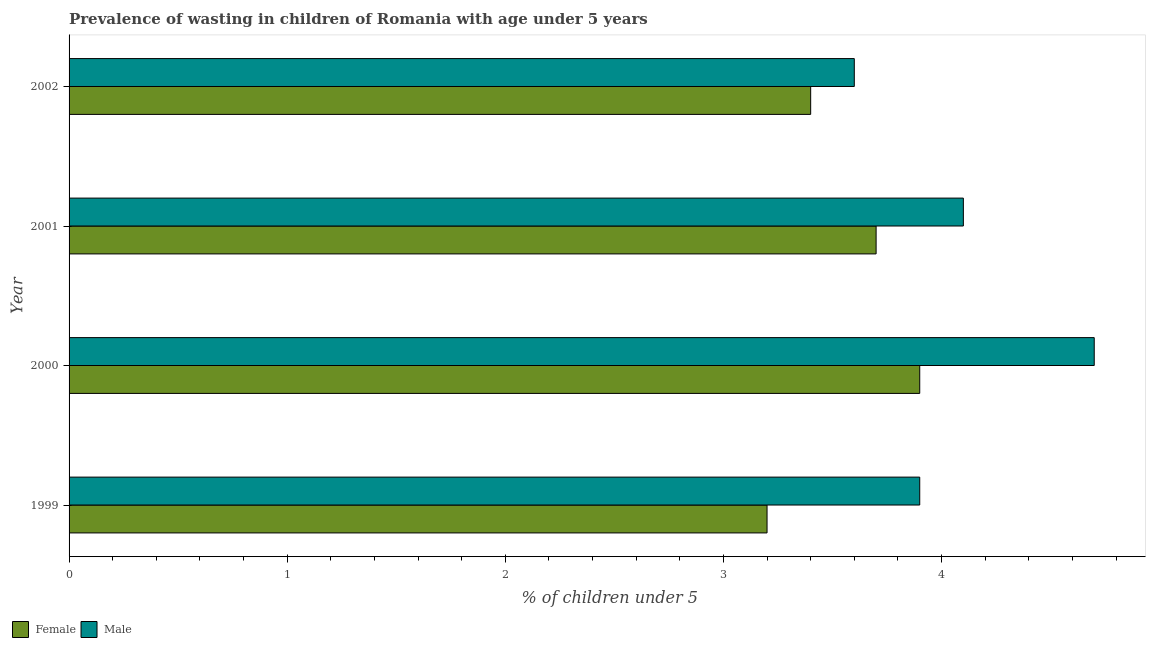How many groups of bars are there?
Your answer should be compact. 4. Are the number of bars per tick equal to the number of legend labels?
Give a very brief answer. Yes. How many bars are there on the 3rd tick from the top?
Your answer should be very brief. 2. How many bars are there on the 1st tick from the bottom?
Keep it short and to the point. 2. What is the label of the 4th group of bars from the top?
Provide a succinct answer. 1999. What is the percentage of undernourished female children in 1999?
Offer a very short reply. 3.2. Across all years, what is the maximum percentage of undernourished male children?
Your response must be concise. 4.7. Across all years, what is the minimum percentage of undernourished male children?
Ensure brevity in your answer.  3.6. What is the total percentage of undernourished male children in the graph?
Give a very brief answer. 16.3. What is the difference between the percentage of undernourished female children in 1999 and that in 2002?
Offer a terse response. -0.2. What is the average percentage of undernourished female children per year?
Ensure brevity in your answer.  3.55. In the year 2001, what is the difference between the percentage of undernourished male children and percentage of undernourished female children?
Offer a very short reply. 0.4. In how many years, is the percentage of undernourished male children greater than 1 %?
Provide a short and direct response. 4. What is the ratio of the percentage of undernourished female children in 1999 to that in 2001?
Ensure brevity in your answer.  0.86. Is the percentage of undernourished female children in 2001 less than that in 2002?
Provide a succinct answer. No. What is the difference between the highest and the second highest percentage of undernourished male children?
Your answer should be compact. 0.6. What is the difference between the highest and the lowest percentage of undernourished male children?
Provide a short and direct response. 1.1. In how many years, is the percentage of undernourished male children greater than the average percentage of undernourished male children taken over all years?
Make the answer very short. 2. Is the sum of the percentage of undernourished female children in 2000 and 2001 greater than the maximum percentage of undernourished male children across all years?
Make the answer very short. Yes. What does the 2nd bar from the top in 2000 represents?
Ensure brevity in your answer.  Female. What does the 1st bar from the bottom in 1999 represents?
Make the answer very short. Female. How many bars are there?
Keep it short and to the point. 8. How many years are there in the graph?
Keep it short and to the point. 4. What is the difference between two consecutive major ticks on the X-axis?
Offer a terse response. 1. Are the values on the major ticks of X-axis written in scientific E-notation?
Give a very brief answer. No. How many legend labels are there?
Make the answer very short. 2. How are the legend labels stacked?
Make the answer very short. Horizontal. What is the title of the graph?
Your answer should be compact. Prevalence of wasting in children of Romania with age under 5 years. What is the label or title of the X-axis?
Provide a succinct answer.  % of children under 5. What is the  % of children under 5 in Female in 1999?
Your answer should be compact. 3.2. What is the  % of children under 5 of Male in 1999?
Make the answer very short. 3.9. What is the  % of children under 5 in Female in 2000?
Provide a short and direct response. 3.9. What is the  % of children under 5 in Male in 2000?
Offer a very short reply. 4.7. What is the  % of children under 5 of Female in 2001?
Give a very brief answer. 3.7. What is the  % of children under 5 in Male in 2001?
Your answer should be compact. 4.1. What is the  % of children under 5 of Female in 2002?
Your answer should be very brief. 3.4. What is the  % of children under 5 in Male in 2002?
Your answer should be compact. 3.6. Across all years, what is the maximum  % of children under 5 in Female?
Your answer should be compact. 3.9. Across all years, what is the maximum  % of children under 5 in Male?
Make the answer very short. 4.7. Across all years, what is the minimum  % of children under 5 of Female?
Make the answer very short. 3.2. Across all years, what is the minimum  % of children under 5 of Male?
Offer a very short reply. 3.6. What is the difference between the  % of children under 5 in Female in 1999 and that in 2000?
Keep it short and to the point. -0.7. What is the difference between the  % of children under 5 in Female in 1999 and that in 2002?
Offer a very short reply. -0.2. What is the difference between the  % of children under 5 in Female in 2000 and that in 2001?
Your response must be concise. 0.2. What is the difference between the  % of children under 5 of Male in 2001 and that in 2002?
Offer a very short reply. 0.5. What is the difference between the  % of children under 5 of Female in 1999 and the  % of children under 5 of Male in 2002?
Provide a succinct answer. -0.4. What is the average  % of children under 5 of Female per year?
Provide a succinct answer. 3.55. What is the average  % of children under 5 in Male per year?
Offer a very short reply. 4.08. In the year 2002, what is the difference between the  % of children under 5 in Female and  % of children under 5 in Male?
Ensure brevity in your answer.  -0.2. What is the ratio of the  % of children under 5 of Female in 1999 to that in 2000?
Offer a very short reply. 0.82. What is the ratio of the  % of children under 5 of Male in 1999 to that in 2000?
Provide a short and direct response. 0.83. What is the ratio of the  % of children under 5 of Female in 1999 to that in 2001?
Your response must be concise. 0.86. What is the ratio of the  % of children under 5 in Male in 1999 to that in 2001?
Keep it short and to the point. 0.95. What is the ratio of the  % of children under 5 of Female in 1999 to that in 2002?
Ensure brevity in your answer.  0.94. What is the ratio of the  % of children under 5 in Male in 1999 to that in 2002?
Your answer should be compact. 1.08. What is the ratio of the  % of children under 5 in Female in 2000 to that in 2001?
Provide a short and direct response. 1.05. What is the ratio of the  % of children under 5 in Male in 2000 to that in 2001?
Ensure brevity in your answer.  1.15. What is the ratio of the  % of children under 5 of Female in 2000 to that in 2002?
Provide a succinct answer. 1.15. What is the ratio of the  % of children under 5 of Male in 2000 to that in 2002?
Keep it short and to the point. 1.31. What is the ratio of the  % of children under 5 in Female in 2001 to that in 2002?
Your answer should be very brief. 1.09. What is the ratio of the  % of children under 5 in Male in 2001 to that in 2002?
Your response must be concise. 1.14. What is the difference between the highest and the second highest  % of children under 5 in Female?
Your answer should be compact. 0.2. What is the difference between the highest and the lowest  % of children under 5 in Female?
Offer a terse response. 0.7. What is the difference between the highest and the lowest  % of children under 5 of Male?
Offer a very short reply. 1.1. 